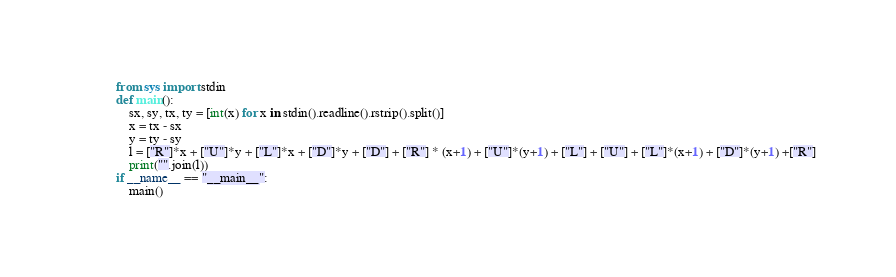Convert code to text. <code><loc_0><loc_0><loc_500><loc_500><_Python_>from sys import stdin
def main():
    sx, sy, tx, ty = [int(x) for x in stdin().readline().rstrip().split()]
    x = tx - sx
    y = ty - sy
    l = ["R"]*x + ["U"]*y + ["L"]*x + ["D"]*y + ["D"] + ["R"] * (x+1) + ["U"]*(y+1) + ["L"] + ["U"] + ["L"]*(x+1) + ["D"]*(y+1) +["R"]
    print("".join(l))
if __name__ == "__main__":
    main()</code> 